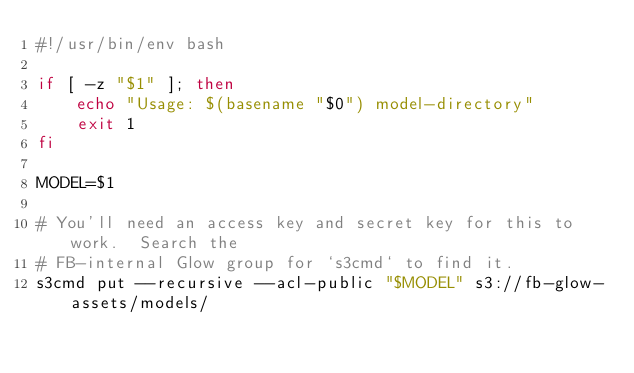<code> <loc_0><loc_0><loc_500><loc_500><_Bash_>#!/usr/bin/env bash

if [ -z "$1" ]; then
    echo "Usage: $(basename "$0") model-directory"
    exit 1
fi

MODEL=$1

# You'll need an access key and secret key for this to work.  Search the
# FB-internal Glow group for `s3cmd` to find it.
s3cmd put --recursive --acl-public "$MODEL" s3://fb-glow-assets/models/
</code> 